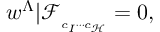Convert formula to latex. <formula><loc_0><loc_0><loc_500><loc_500>w ^ { \Lambda } | \mathcal { F } _ { _ { c _ { I } \cdots c _ { \mathcal { H } } } } = 0 ,</formula> 